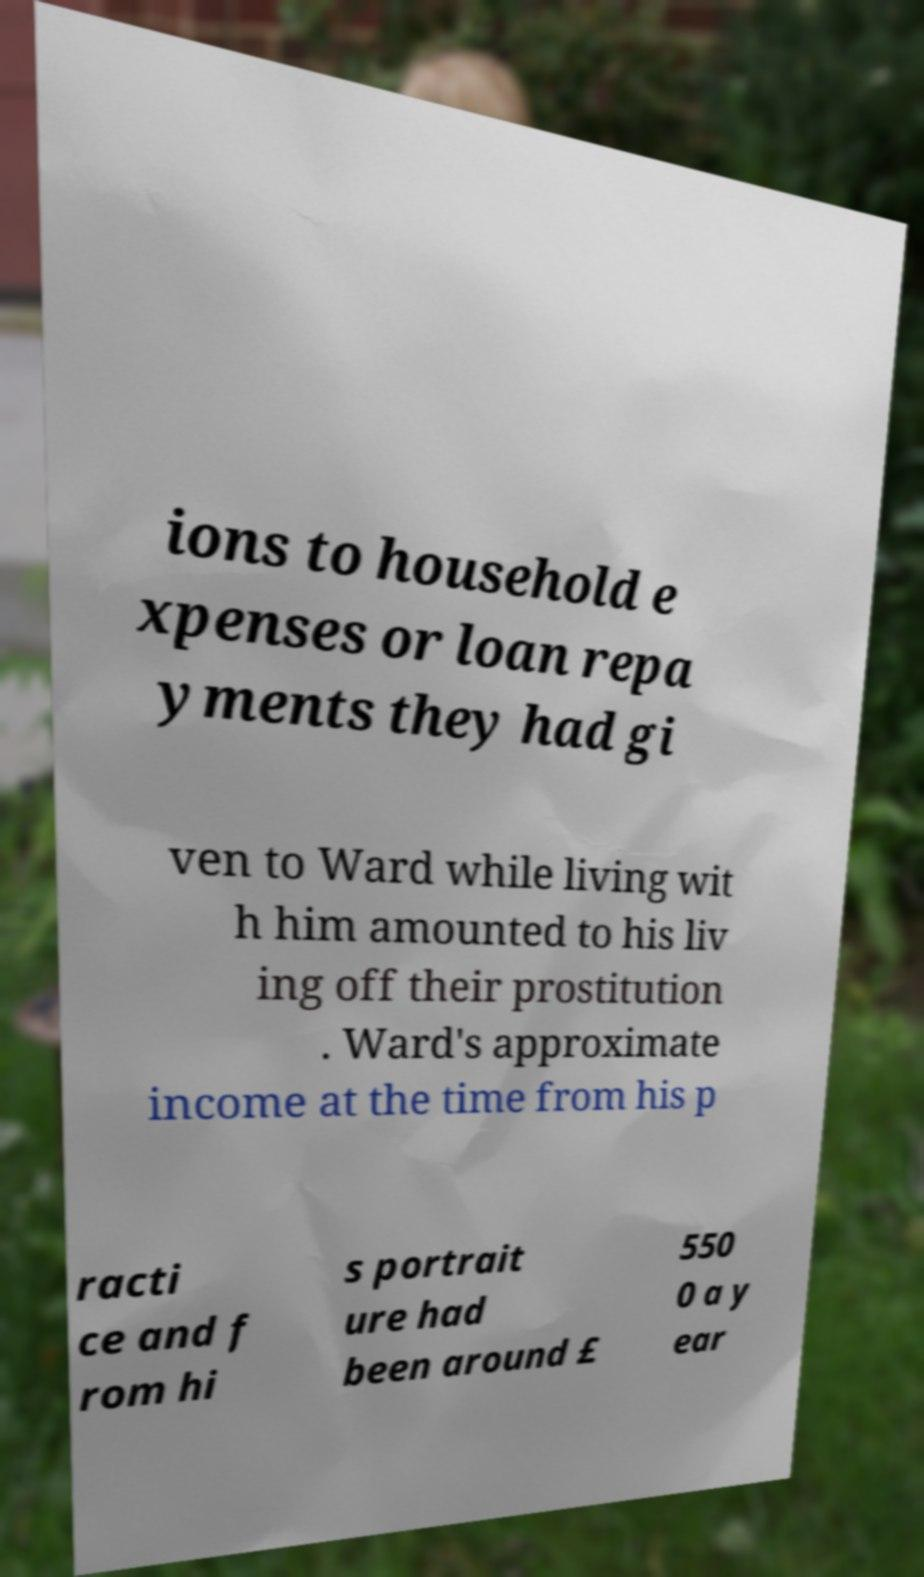There's text embedded in this image that I need extracted. Can you transcribe it verbatim? ions to household e xpenses or loan repa yments they had gi ven to Ward while living wit h him amounted to his liv ing off their prostitution . Ward's approximate income at the time from his p racti ce and f rom hi s portrait ure had been around £ 550 0 a y ear 